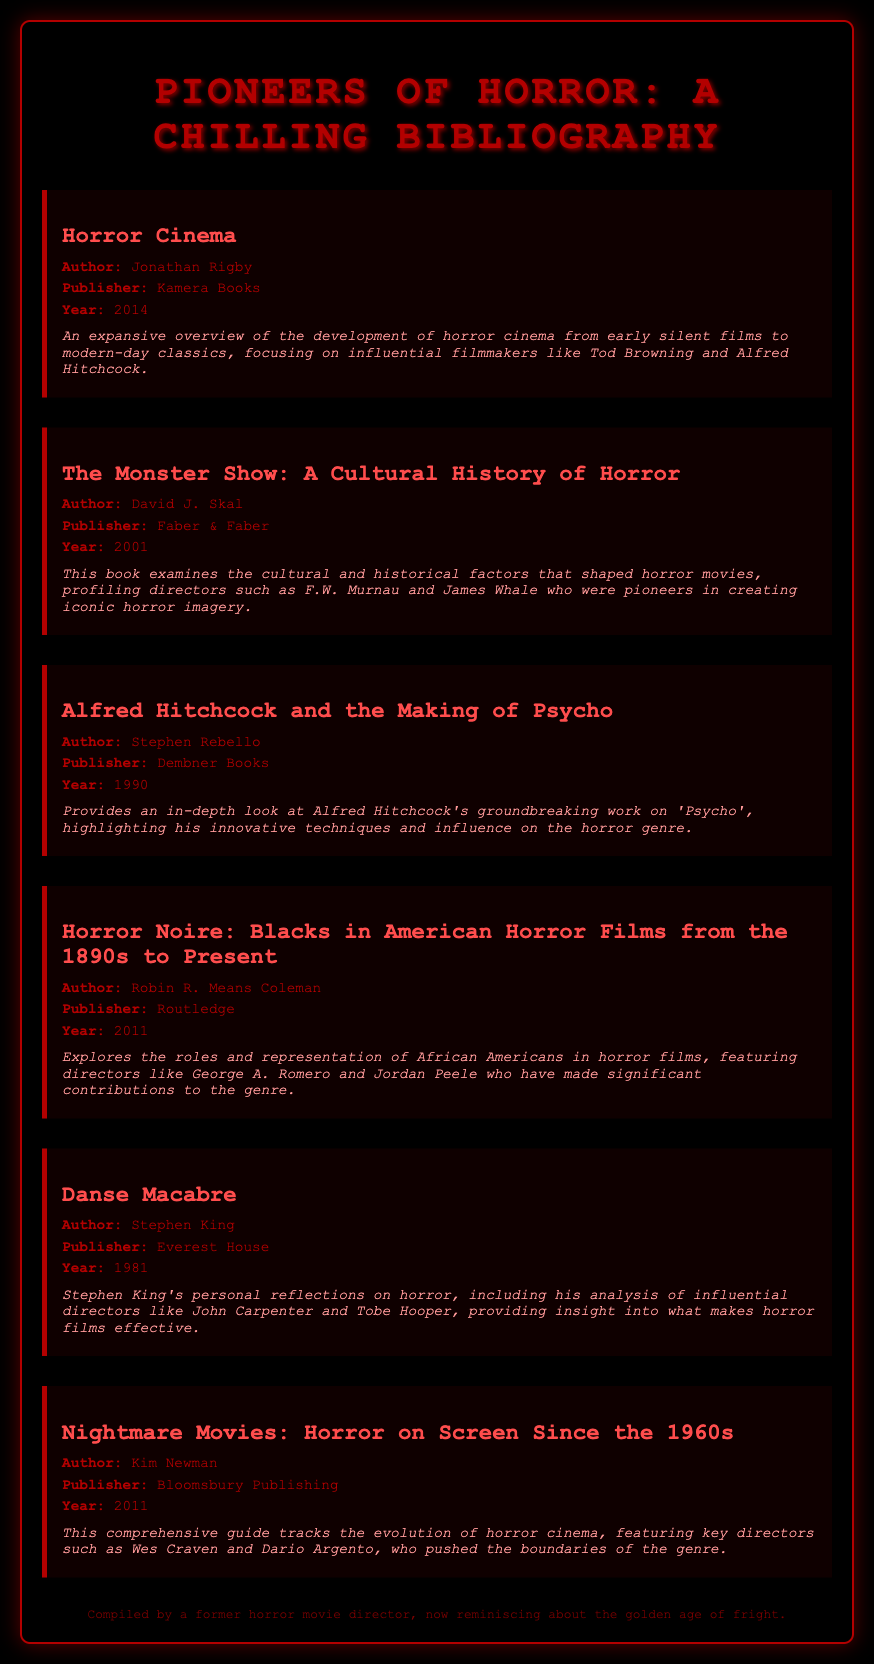what is the title of the first book listed? The title of the first book is mentioned at the top of the bibliography section, which is "Horror Cinema."
Answer: Horror Cinema who is the author of "The Monster Show: A Cultural History of Horror"? The author of "The Monster Show: A Cultural History of Horror" is indicated in the document as David J. Skal.
Answer: David J. Skal which year was "Alfred Hitchcock and the Making of Psycho" published? The publication year for "Alfred Hitchcock and the Making of Psycho" is listed in the book details as 1990.
Answer: 1990 how many books are listed in the bibliography? The total number of books can be counted from the document, and there are six books present.
Answer: 6 who wrote "Danse Macabre"? The author of "Danse Macabre" is stated in the document, which is Stephen King.
Answer: Stephen King what is a common theme among the directors discussed in the bibliography? An analysis of the document reveals that a common theme among the directors is their significant contributions to the horror genre.
Answer: Contributions to the horror genre which publisher produced "Horror Noire: Blacks in American Horror Films from the 1890s to Present"? The publisher for "Horror Noire: Blacks in American Horror Films from the 1890s to Present" is mentioned as Routledge.
Answer: Routledge what film is highlighted in Stephen Rebello's book? The film highlighted in Stephen Rebello's book is "Psycho," as noted in the description.
Answer: Psycho 